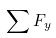Convert formula to latex. <formula><loc_0><loc_0><loc_500><loc_500>\sum F _ { y }</formula> 